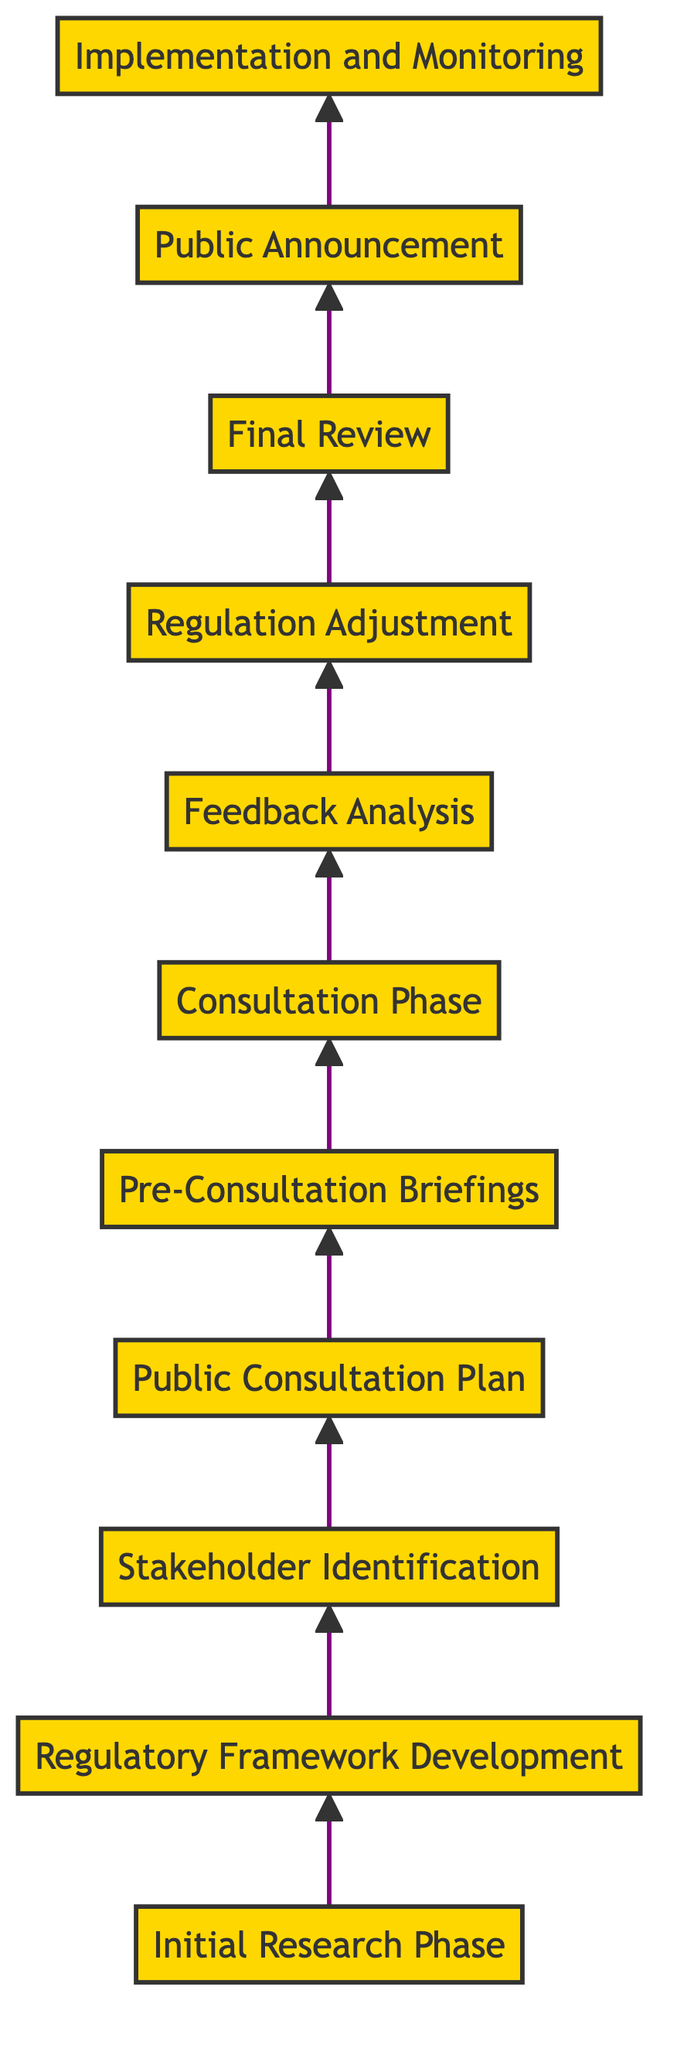What is the first phase in the diagram? The diagram starts with the node labeled "Initial Research Phase," which is the first step in the pathway to public consultation and stakeholder engagement in genetic engineering.
Answer: Initial Research Phase How many total phases are there in the diagram? By counting the nodes in the flowchart, there are a total of 11 distinct phases listed, from "Initial Research Phase" to "Implementation and Monitoring."
Answer: 11 What phase follows the "Stakeholder Identification"? The diagram flows from "Stakeholder Identification" to "Public Consultation Plan," indicating the order of activities from one phase to the next.
Answer: Public Consultation Plan What is the last phase in the diagram? The last node in the upward flow of the diagram is "Implementation and Monitoring," which concludes the sequence of phases.
Answer: Implementation and Monitoring Which phase involves analyzing feedback? The phase labeled "Feedback Analysis" is specifically focused on the analysis of feedback received during the consultation process.
Answer: Feedback Analysis What is the relationship between "Feedback Analysis" and "Regulation Adjustment"? "Feedback Analysis" serves as a precursor to "Regulation Adjustment," indicating that after feedback is analyzed, the regulatory framework may be revised accordingly.
Answer: Preceding phase What is the purpose of the "Public Consultation Plan"? The "Public Consultation Plan" is designed to outline strategies for engaging the public through various methods, such as forums and surveys, ensuring open communication.
Answer: Engagement strategy Which phases involve direct public interaction? The phases that involve direct public interaction are "Public Consultation Plan," "Consultation Phase," and "Public Announcement," as they are focused on communication with the public.
Answer: Three phases What occurs after the "Consultation Phase"? Following the "Consultation Phase," the next step is "Feedback Analysis," where the collected feedback and concerns are reviewed and summarized.
Answer: Feedback Analysis What is the overall goal of the pathway represented in the diagram? The pathway in the diagram ultimately aims to ensure that the regulations developed for genetic engineering are inclusive and well-informed by public and stakeholder input throughout the process.
Answer: Inclusive and informed regulations 